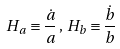<formula> <loc_0><loc_0><loc_500><loc_500>H _ { a } \equiv \frac { \dot { a } } { a } \, , \, H _ { b } \equiv \frac { \dot { b } } { b }</formula> 